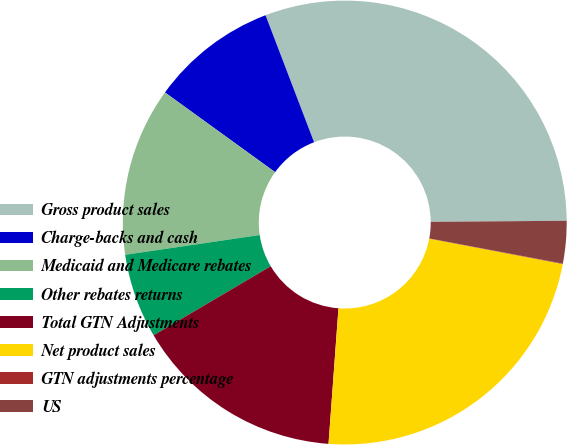Convert chart to OTSL. <chart><loc_0><loc_0><loc_500><loc_500><pie_chart><fcel>Gross product sales<fcel>Charge-backs and cash<fcel>Medicaid and Medicare rebates<fcel>Other rebates returns<fcel>Total GTN Adjustments<fcel>Net product sales<fcel>GTN adjustments percentage<fcel>US<nl><fcel>30.68%<fcel>9.22%<fcel>12.29%<fcel>6.16%<fcel>15.35%<fcel>23.17%<fcel>0.03%<fcel>3.09%<nl></chart> 